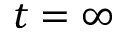<formula> <loc_0><loc_0><loc_500><loc_500>t = \infty</formula> 